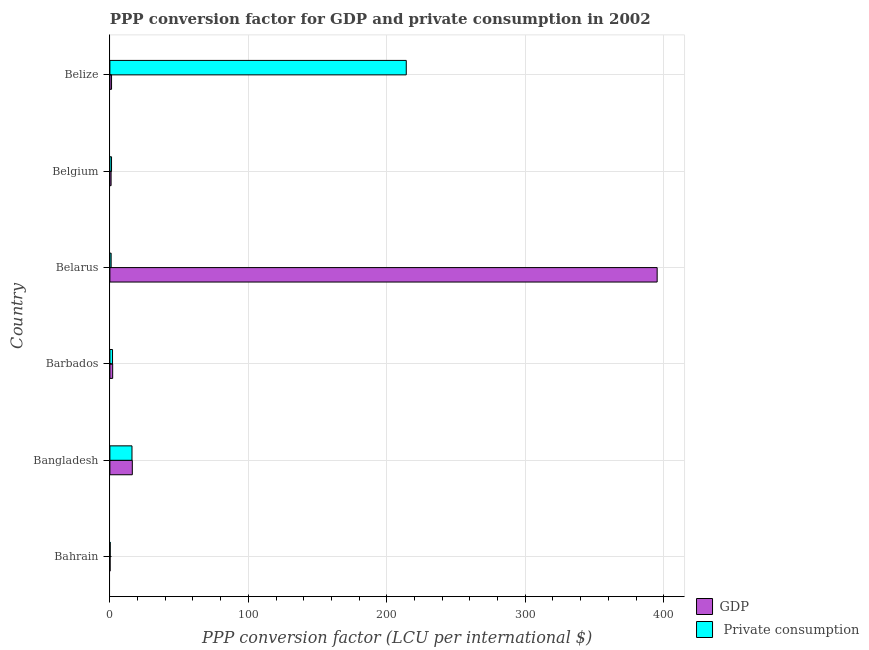How many different coloured bars are there?
Offer a very short reply. 2. Are the number of bars per tick equal to the number of legend labels?
Ensure brevity in your answer.  Yes. Are the number of bars on each tick of the Y-axis equal?
Offer a very short reply. Yes. How many bars are there on the 1st tick from the top?
Make the answer very short. 2. What is the label of the 5th group of bars from the top?
Make the answer very short. Bangladesh. In how many cases, is the number of bars for a given country not equal to the number of legend labels?
Offer a very short reply. 0. What is the ppp conversion factor for gdp in Barbados?
Provide a short and direct response. 2.01. Across all countries, what is the maximum ppp conversion factor for private consumption?
Ensure brevity in your answer.  214.04. Across all countries, what is the minimum ppp conversion factor for private consumption?
Make the answer very short. 0.22. In which country was the ppp conversion factor for gdp maximum?
Make the answer very short. Belarus. In which country was the ppp conversion factor for gdp minimum?
Your answer should be very brief. Bahrain. What is the total ppp conversion factor for private consumption in the graph?
Make the answer very short. 234.2. What is the difference between the ppp conversion factor for gdp in Bahrain and that in Belarus?
Make the answer very short. -395.1. What is the difference between the ppp conversion factor for gdp in Bahrain and the ppp conversion factor for private consumption in Belize?
Your answer should be very brief. -213.9. What is the average ppp conversion factor for private consumption per country?
Your answer should be very brief. 39.03. What is the difference between the ppp conversion factor for gdp and ppp conversion factor for private consumption in Bangladesh?
Your answer should be compact. 0.25. What is the ratio of the ppp conversion factor for private consumption in Barbados to that in Belgium?
Give a very brief answer. 1.61. Is the ppp conversion factor for private consumption in Belarus less than that in Belize?
Your answer should be very brief. Yes. What is the difference between the highest and the second highest ppp conversion factor for gdp?
Offer a very short reply. 379.04. What is the difference between the highest and the lowest ppp conversion factor for private consumption?
Your answer should be very brief. 213.82. Is the sum of the ppp conversion factor for gdp in Bahrain and Bangladesh greater than the maximum ppp conversion factor for private consumption across all countries?
Your answer should be compact. No. What does the 1st bar from the top in Bangladesh represents?
Your answer should be compact.  Private consumption. What does the 1st bar from the bottom in Belgium represents?
Ensure brevity in your answer.  GDP. What is the difference between two consecutive major ticks on the X-axis?
Offer a very short reply. 100. Does the graph contain grids?
Keep it short and to the point. Yes. Where does the legend appear in the graph?
Give a very brief answer. Bottom right. How many legend labels are there?
Offer a terse response. 2. What is the title of the graph?
Keep it short and to the point. PPP conversion factor for GDP and private consumption in 2002. Does "Constant 2005 US$" appear as one of the legend labels in the graph?
Keep it short and to the point. No. What is the label or title of the X-axis?
Offer a terse response. PPP conversion factor (LCU per international $). What is the PPP conversion factor (LCU per international $) of GDP in Bahrain?
Your response must be concise. 0.14. What is the PPP conversion factor (LCU per international $) in  Private consumption in Bahrain?
Make the answer very short. 0.22. What is the PPP conversion factor (LCU per international $) of GDP in Bangladesh?
Offer a terse response. 16.2. What is the PPP conversion factor (LCU per international $) of  Private consumption in Bangladesh?
Ensure brevity in your answer.  15.95. What is the PPP conversion factor (LCU per international $) of GDP in Barbados?
Your response must be concise. 2.01. What is the PPP conversion factor (LCU per international $) in  Private consumption in Barbados?
Make the answer very short. 1.91. What is the PPP conversion factor (LCU per international $) of GDP in Belarus?
Make the answer very short. 395.24. What is the PPP conversion factor (LCU per international $) of  Private consumption in Belarus?
Provide a short and direct response. 0.9. What is the PPP conversion factor (LCU per international $) of GDP in Belgium?
Make the answer very short. 0.87. What is the PPP conversion factor (LCU per international $) of  Private consumption in Belgium?
Give a very brief answer. 1.18. What is the PPP conversion factor (LCU per international $) in GDP in Belize?
Keep it short and to the point. 1.19. What is the PPP conversion factor (LCU per international $) of  Private consumption in Belize?
Your answer should be compact. 214.04. Across all countries, what is the maximum PPP conversion factor (LCU per international $) of GDP?
Provide a short and direct response. 395.24. Across all countries, what is the maximum PPP conversion factor (LCU per international $) of  Private consumption?
Your answer should be very brief. 214.04. Across all countries, what is the minimum PPP conversion factor (LCU per international $) in GDP?
Offer a terse response. 0.14. Across all countries, what is the minimum PPP conversion factor (LCU per international $) of  Private consumption?
Your answer should be very brief. 0.22. What is the total PPP conversion factor (LCU per international $) of GDP in the graph?
Your answer should be compact. 415.64. What is the total PPP conversion factor (LCU per international $) of  Private consumption in the graph?
Make the answer very short. 234.2. What is the difference between the PPP conversion factor (LCU per international $) in GDP in Bahrain and that in Bangladesh?
Offer a very short reply. -16.06. What is the difference between the PPP conversion factor (LCU per international $) of  Private consumption in Bahrain and that in Bangladesh?
Offer a terse response. -15.73. What is the difference between the PPP conversion factor (LCU per international $) of GDP in Bahrain and that in Barbados?
Give a very brief answer. -1.87. What is the difference between the PPP conversion factor (LCU per international $) in  Private consumption in Bahrain and that in Barbados?
Offer a terse response. -1.68. What is the difference between the PPP conversion factor (LCU per international $) of GDP in Bahrain and that in Belarus?
Your response must be concise. -395.1. What is the difference between the PPP conversion factor (LCU per international $) in  Private consumption in Bahrain and that in Belarus?
Offer a terse response. -0.68. What is the difference between the PPP conversion factor (LCU per international $) of GDP in Bahrain and that in Belgium?
Provide a short and direct response. -0.73. What is the difference between the PPP conversion factor (LCU per international $) of  Private consumption in Bahrain and that in Belgium?
Ensure brevity in your answer.  -0.96. What is the difference between the PPP conversion factor (LCU per international $) of GDP in Bahrain and that in Belize?
Offer a terse response. -1.05. What is the difference between the PPP conversion factor (LCU per international $) of  Private consumption in Bahrain and that in Belize?
Make the answer very short. -213.82. What is the difference between the PPP conversion factor (LCU per international $) in GDP in Bangladesh and that in Barbados?
Make the answer very short. 14.19. What is the difference between the PPP conversion factor (LCU per international $) in  Private consumption in Bangladesh and that in Barbados?
Give a very brief answer. 14.04. What is the difference between the PPP conversion factor (LCU per international $) of GDP in Bangladesh and that in Belarus?
Provide a succinct answer. -379.04. What is the difference between the PPP conversion factor (LCU per international $) of  Private consumption in Bangladesh and that in Belarus?
Keep it short and to the point. 15.05. What is the difference between the PPP conversion factor (LCU per international $) of GDP in Bangladesh and that in Belgium?
Your response must be concise. 15.33. What is the difference between the PPP conversion factor (LCU per international $) in  Private consumption in Bangladesh and that in Belgium?
Your answer should be very brief. 14.77. What is the difference between the PPP conversion factor (LCU per international $) of GDP in Bangladesh and that in Belize?
Offer a terse response. 15.01. What is the difference between the PPP conversion factor (LCU per international $) of  Private consumption in Bangladesh and that in Belize?
Provide a succinct answer. -198.09. What is the difference between the PPP conversion factor (LCU per international $) of GDP in Barbados and that in Belarus?
Make the answer very short. -393.23. What is the difference between the PPP conversion factor (LCU per international $) in  Private consumption in Barbados and that in Belarus?
Your answer should be compact. 1.01. What is the difference between the PPP conversion factor (LCU per international $) in GDP in Barbados and that in Belgium?
Your answer should be very brief. 1.14. What is the difference between the PPP conversion factor (LCU per international $) of  Private consumption in Barbados and that in Belgium?
Make the answer very short. 0.72. What is the difference between the PPP conversion factor (LCU per international $) in GDP in Barbados and that in Belize?
Keep it short and to the point. 0.82. What is the difference between the PPP conversion factor (LCU per international $) in  Private consumption in Barbados and that in Belize?
Keep it short and to the point. -212.14. What is the difference between the PPP conversion factor (LCU per international $) of GDP in Belarus and that in Belgium?
Your response must be concise. 394.37. What is the difference between the PPP conversion factor (LCU per international $) of  Private consumption in Belarus and that in Belgium?
Your answer should be compact. -0.28. What is the difference between the PPP conversion factor (LCU per international $) of GDP in Belarus and that in Belize?
Ensure brevity in your answer.  394.05. What is the difference between the PPP conversion factor (LCU per international $) in  Private consumption in Belarus and that in Belize?
Provide a short and direct response. -213.14. What is the difference between the PPP conversion factor (LCU per international $) of GDP in Belgium and that in Belize?
Your response must be concise. -0.33. What is the difference between the PPP conversion factor (LCU per international $) of  Private consumption in Belgium and that in Belize?
Give a very brief answer. -212.86. What is the difference between the PPP conversion factor (LCU per international $) in GDP in Bahrain and the PPP conversion factor (LCU per international $) in  Private consumption in Bangladesh?
Keep it short and to the point. -15.81. What is the difference between the PPP conversion factor (LCU per international $) of GDP in Bahrain and the PPP conversion factor (LCU per international $) of  Private consumption in Barbados?
Your answer should be compact. -1.77. What is the difference between the PPP conversion factor (LCU per international $) of GDP in Bahrain and the PPP conversion factor (LCU per international $) of  Private consumption in Belarus?
Offer a very short reply. -0.76. What is the difference between the PPP conversion factor (LCU per international $) of GDP in Bahrain and the PPP conversion factor (LCU per international $) of  Private consumption in Belgium?
Keep it short and to the point. -1.04. What is the difference between the PPP conversion factor (LCU per international $) of GDP in Bahrain and the PPP conversion factor (LCU per international $) of  Private consumption in Belize?
Keep it short and to the point. -213.9. What is the difference between the PPP conversion factor (LCU per international $) in GDP in Bangladesh and the PPP conversion factor (LCU per international $) in  Private consumption in Barbados?
Offer a very short reply. 14.29. What is the difference between the PPP conversion factor (LCU per international $) in GDP in Bangladesh and the PPP conversion factor (LCU per international $) in  Private consumption in Belarus?
Make the answer very short. 15.3. What is the difference between the PPP conversion factor (LCU per international $) in GDP in Bangladesh and the PPP conversion factor (LCU per international $) in  Private consumption in Belgium?
Your response must be concise. 15.02. What is the difference between the PPP conversion factor (LCU per international $) of GDP in Bangladesh and the PPP conversion factor (LCU per international $) of  Private consumption in Belize?
Provide a succinct answer. -197.84. What is the difference between the PPP conversion factor (LCU per international $) in GDP in Barbados and the PPP conversion factor (LCU per international $) in  Private consumption in Belarus?
Provide a succinct answer. 1.11. What is the difference between the PPP conversion factor (LCU per international $) in GDP in Barbados and the PPP conversion factor (LCU per international $) in  Private consumption in Belgium?
Offer a very short reply. 0.83. What is the difference between the PPP conversion factor (LCU per international $) of GDP in Barbados and the PPP conversion factor (LCU per international $) of  Private consumption in Belize?
Your response must be concise. -212.03. What is the difference between the PPP conversion factor (LCU per international $) of GDP in Belarus and the PPP conversion factor (LCU per international $) of  Private consumption in Belgium?
Your response must be concise. 394.06. What is the difference between the PPP conversion factor (LCU per international $) of GDP in Belarus and the PPP conversion factor (LCU per international $) of  Private consumption in Belize?
Offer a very short reply. 181.2. What is the difference between the PPP conversion factor (LCU per international $) in GDP in Belgium and the PPP conversion factor (LCU per international $) in  Private consumption in Belize?
Your answer should be very brief. -213.18. What is the average PPP conversion factor (LCU per international $) of GDP per country?
Ensure brevity in your answer.  69.27. What is the average PPP conversion factor (LCU per international $) of  Private consumption per country?
Offer a very short reply. 39.03. What is the difference between the PPP conversion factor (LCU per international $) of GDP and PPP conversion factor (LCU per international $) of  Private consumption in Bahrain?
Your answer should be very brief. -0.08. What is the difference between the PPP conversion factor (LCU per international $) of GDP and PPP conversion factor (LCU per international $) of  Private consumption in Bangladesh?
Make the answer very short. 0.25. What is the difference between the PPP conversion factor (LCU per international $) in GDP and PPP conversion factor (LCU per international $) in  Private consumption in Barbados?
Your answer should be compact. 0.1. What is the difference between the PPP conversion factor (LCU per international $) of GDP and PPP conversion factor (LCU per international $) of  Private consumption in Belarus?
Offer a very short reply. 394.34. What is the difference between the PPP conversion factor (LCU per international $) in GDP and PPP conversion factor (LCU per international $) in  Private consumption in Belgium?
Give a very brief answer. -0.32. What is the difference between the PPP conversion factor (LCU per international $) in GDP and PPP conversion factor (LCU per international $) in  Private consumption in Belize?
Your response must be concise. -212.85. What is the ratio of the PPP conversion factor (LCU per international $) of GDP in Bahrain to that in Bangladesh?
Provide a short and direct response. 0.01. What is the ratio of the PPP conversion factor (LCU per international $) of  Private consumption in Bahrain to that in Bangladesh?
Provide a succinct answer. 0.01. What is the ratio of the PPP conversion factor (LCU per international $) in GDP in Bahrain to that in Barbados?
Keep it short and to the point. 0.07. What is the ratio of the PPP conversion factor (LCU per international $) of  Private consumption in Bahrain to that in Barbados?
Make the answer very short. 0.12. What is the ratio of the PPP conversion factor (LCU per international $) in GDP in Bahrain to that in Belarus?
Ensure brevity in your answer.  0. What is the ratio of the PPP conversion factor (LCU per international $) in  Private consumption in Bahrain to that in Belarus?
Make the answer very short. 0.25. What is the ratio of the PPP conversion factor (LCU per international $) in GDP in Bahrain to that in Belgium?
Your answer should be very brief. 0.16. What is the ratio of the PPP conversion factor (LCU per international $) of  Private consumption in Bahrain to that in Belgium?
Your response must be concise. 0.19. What is the ratio of the PPP conversion factor (LCU per international $) of GDP in Bahrain to that in Belize?
Your answer should be very brief. 0.12. What is the ratio of the PPP conversion factor (LCU per international $) in GDP in Bangladesh to that in Barbados?
Make the answer very short. 8.06. What is the ratio of the PPP conversion factor (LCU per international $) in  Private consumption in Bangladesh to that in Barbados?
Provide a succinct answer. 8.37. What is the ratio of the PPP conversion factor (LCU per international $) in GDP in Bangladesh to that in Belarus?
Your answer should be compact. 0.04. What is the ratio of the PPP conversion factor (LCU per international $) in  Private consumption in Bangladesh to that in Belarus?
Offer a terse response. 17.79. What is the ratio of the PPP conversion factor (LCU per international $) of GDP in Bangladesh to that in Belgium?
Your answer should be very brief. 18.72. What is the ratio of the PPP conversion factor (LCU per international $) in  Private consumption in Bangladesh to that in Belgium?
Provide a short and direct response. 13.5. What is the ratio of the PPP conversion factor (LCU per international $) in GDP in Bangladesh to that in Belize?
Your response must be concise. 13.58. What is the ratio of the PPP conversion factor (LCU per international $) in  Private consumption in Bangladesh to that in Belize?
Make the answer very short. 0.07. What is the ratio of the PPP conversion factor (LCU per international $) in GDP in Barbados to that in Belarus?
Offer a terse response. 0.01. What is the ratio of the PPP conversion factor (LCU per international $) in  Private consumption in Barbados to that in Belarus?
Your response must be concise. 2.13. What is the ratio of the PPP conversion factor (LCU per international $) of GDP in Barbados to that in Belgium?
Offer a very short reply. 2.32. What is the ratio of the PPP conversion factor (LCU per international $) in  Private consumption in Barbados to that in Belgium?
Your answer should be compact. 1.61. What is the ratio of the PPP conversion factor (LCU per international $) in GDP in Barbados to that in Belize?
Provide a succinct answer. 1.68. What is the ratio of the PPP conversion factor (LCU per international $) in  Private consumption in Barbados to that in Belize?
Keep it short and to the point. 0.01. What is the ratio of the PPP conversion factor (LCU per international $) of GDP in Belarus to that in Belgium?
Provide a short and direct response. 456.81. What is the ratio of the PPP conversion factor (LCU per international $) of  Private consumption in Belarus to that in Belgium?
Make the answer very short. 0.76. What is the ratio of the PPP conversion factor (LCU per international $) in GDP in Belarus to that in Belize?
Offer a very short reply. 331.49. What is the ratio of the PPP conversion factor (LCU per international $) in  Private consumption in Belarus to that in Belize?
Offer a very short reply. 0. What is the ratio of the PPP conversion factor (LCU per international $) in GDP in Belgium to that in Belize?
Provide a short and direct response. 0.73. What is the ratio of the PPP conversion factor (LCU per international $) of  Private consumption in Belgium to that in Belize?
Keep it short and to the point. 0.01. What is the difference between the highest and the second highest PPP conversion factor (LCU per international $) in GDP?
Offer a very short reply. 379.04. What is the difference between the highest and the second highest PPP conversion factor (LCU per international $) in  Private consumption?
Make the answer very short. 198.09. What is the difference between the highest and the lowest PPP conversion factor (LCU per international $) in GDP?
Provide a short and direct response. 395.1. What is the difference between the highest and the lowest PPP conversion factor (LCU per international $) in  Private consumption?
Give a very brief answer. 213.82. 